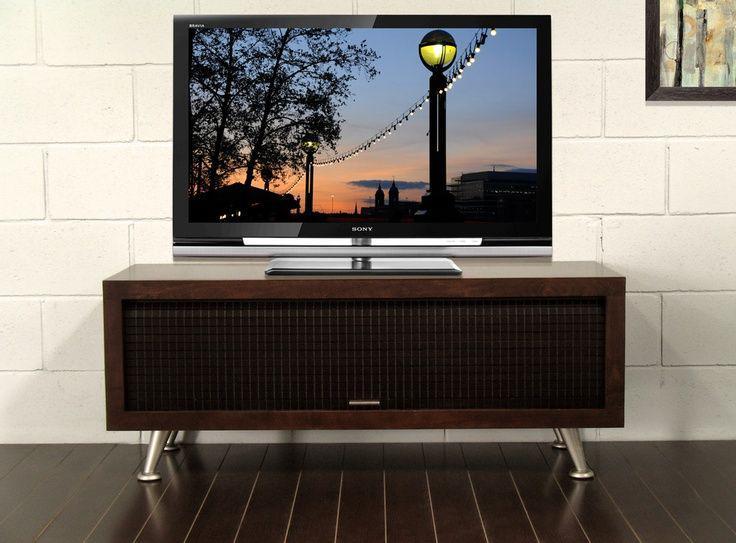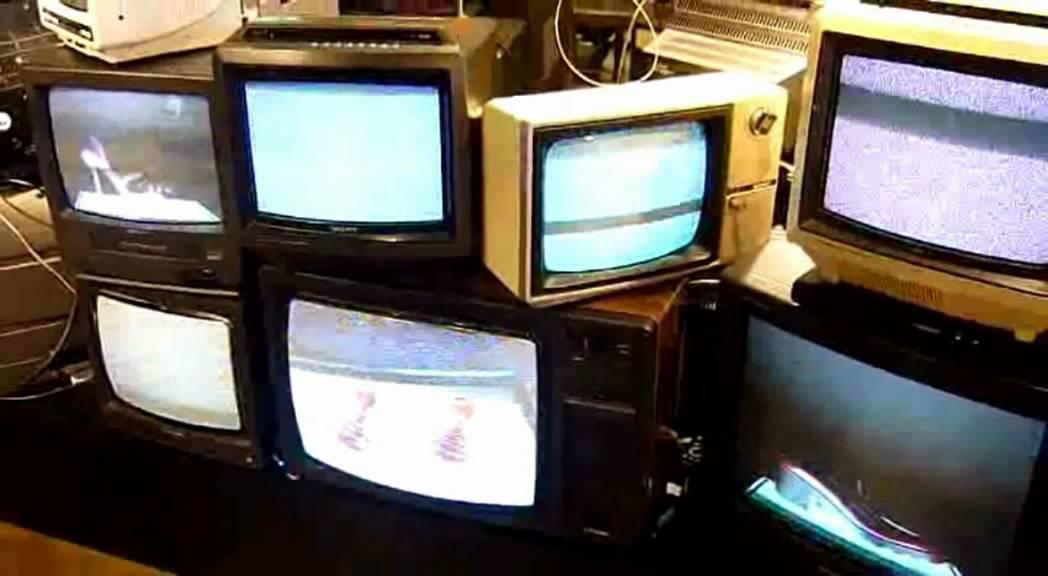The first image is the image on the left, the second image is the image on the right. Given the left and right images, does the statement "There is one tube type television in the image on the left." hold true? Answer yes or no. No. 